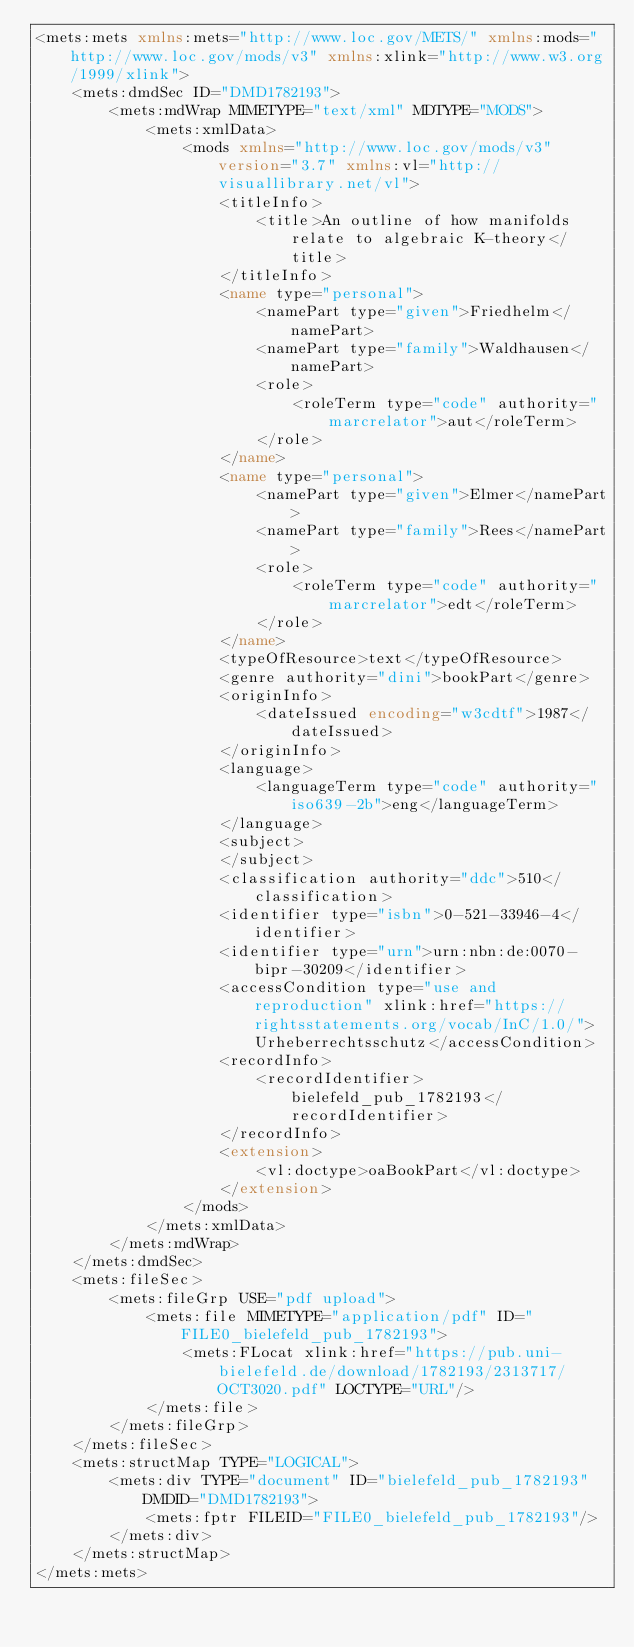Convert code to text. <code><loc_0><loc_0><loc_500><loc_500><_XML_><mets:mets xmlns:mets="http://www.loc.gov/METS/" xmlns:mods="http://www.loc.gov/mods/v3" xmlns:xlink="http://www.w3.org/1999/xlink">
    <mets:dmdSec ID="DMD1782193">
        <mets:mdWrap MIMETYPE="text/xml" MDTYPE="MODS">
            <mets:xmlData>
                <mods xmlns="http://www.loc.gov/mods/v3" version="3.7" xmlns:vl="http://visuallibrary.net/vl">
                    <titleInfo>
                        <title>An outline of how manifolds relate to algebraic K-theory</title>
                    </titleInfo>
                    <name type="personal">
                        <namePart type="given">Friedhelm</namePart>
                        <namePart type="family">Waldhausen</namePart>
                        <role>
                            <roleTerm type="code" authority="marcrelator">aut</roleTerm>
                        </role>
                    </name>
                    <name type="personal">
                        <namePart type="given">Elmer</namePart>
                        <namePart type="family">Rees</namePart>
                        <role>
                            <roleTerm type="code" authority="marcrelator">edt</roleTerm>
                        </role>
                    </name>
                    <typeOfResource>text</typeOfResource>
                    <genre authority="dini">bookPart</genre>
                    <originInfo>
                        <dateIssued encoding="w3cdtf">1987</dateIssued>
                    </originInfo>
                    <language>
                        <languageTerm type="code" authority="iso639-2b">eng</languageTerm>
                    </language>
                    <subject>
                    </subject>
                    <classification authority="ddc">510</classification>
                    <identifier type="isbn">0-521-33946-4</identifier>
                    <identifier type="urn">urn:nbn:de:0070-bipr-30209</identifier>
                    <accessCondition type="use and reproduction" xlink:href="https://rightsstatements.org/vocab/InC/1.0/">Urheberrechtsschutz</accessCondition>
                    <recordInfo>
                        <recordIdentifier>bielefeld_pub_1782193</recordIdentifier>
                    </recordInfo>
                    <extension>
                        <vl:doctype>oaBookPart</vl:doctype>
                    </extension>
                </mods>
            </mets:xmlData>
        </mets:mdWrap>
    </mets:dmdSec>
    <mets:fileSec>
        <mets:fileGrp USE="pdf upload">
            <mets:file MIMETYPE="application/pdf" ID="FILE0_bielefeld_pub_1782193">
                <mets:FLocat xlink:href="https://pub.uni-bielefeld.de/download/1782193/2313717/OCT3020.pdf" LOCTYPE="URL"/>
            </mets:file>
        </mets:fileGrp>
    </mets:fileSec>
    <mets:structMap TYPE="LOGICAL">
        <mets:div TYPE="document" ID="bielefeld_pub_1782193" DMDID="DMD1782193">
            <mets:fptr FILEID="FILE0_bielefeld_pub_1782193"/>
        </mets:div>
    </mets:structMap>
</mets:mets>
</code> 